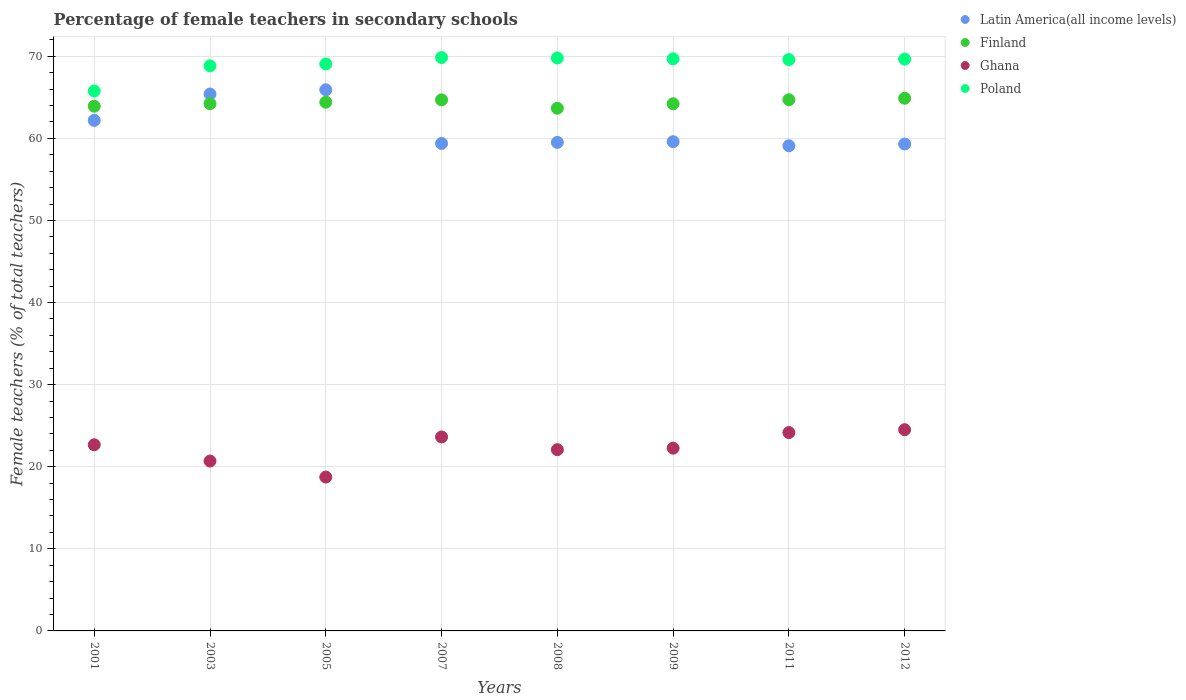What is the percentage of female teachers in Ghana in 2005?
Your response must be concise. 18.74. Across all years, what is the maximum percentage of female teachers in Finland?
Provide a short and direct response. 64.88. Across all years, what is the minimum percentage of female teachers in Finland?
Provide a succinct answer. 63.67. In which year was the percentage of female teachers in Finland maximum?
Your answer should be compact. 2012. In which year was the percentage of female teachers in Poland minimum?
Offer a terse response. 2001. What is the total percentage of female teachers in Poland in the graph?
Your answer should be very brief. 552.22. What is the difference between the percentage of female teachers in Ghana in 2009 and that in 2011?
Offer a terse response. -1.9. What is the difference between the percentage of female teachers in Finland in 2003 and the percentage of female teachers in Poland in 2005?
Give a very brief answer. -4.83. What is the average percentage of female teachers in Latin America(all income levels) per year?
Make the answer very short. 61.3. In the year 2012, what is the difference between the percentage of female teachers in Poland and percentage of female teachers in Finland?
Keep it short and to the point. 4.77. In how many years, is the percentage of female teachers in Poland greater than 24 %?
Ensure brevity in your answer.  8. What is the ratio of the percentage of female teachers in Latin America(all income levels) in 2001 to that in 2007?
Offer a terse response. 1.05. Is the difference between the percentage of female teachers in Poland in 2007 and 2011 greater than the difference between the percentage of female teachers in Finland in 2007 and 2011?
Provide a short and direct response. Yes. What is the difference between the highest and the second highest percentage of female teachers in Finland?
Make the answer very short. 0.18. What is the difference between the highest and the lowest percentage of female teachers in Ghana?
Ensure brevity in your answer.  5.77. In how many years, is the percentage of female teachers in Latin America(all income levels) greater than the average percentage of female teachers in Latin America(all income levels) taken over all years?
Your answer should be very brief. 3. Is the sum of the percentage of female teachers in Poland in 2007 and 2008 greater than the maximum percentage of female teachers in Latin America(all income levels) across all years?
Your answer should be very brief. Yes. Is it the case that in every year, the sum of the percentage of female teachers in Finland and percentage of female teachers in Latin America(all income levels)  is greater than the sum of percentage of female teachers in Poland and percentage of female teachers in Ghana?
Provide a succinct answer. No. Is the percentage of female teachers in Finland strictly greater than the percentage of female teachers in Ghana over the years?
Offer a terse response. Yes. How many years are there in the graph?
Offer a terse response. 8. Does the graph contain any zero values?
Make the answer very short. No. Does the graph contain grids?
Ensure brevity in your answer.  Yes. How many legend labels are there?
Your response must be concise. 4. What is the title of the graph?
Your answer should be compact. Percentage of female teachers in secondary schools. Does "Russian Federation" appear as one of the legend labels in the graph?
Make the answer very short. No. What is the label or title of the Y-axis?
Provide a succinct answer. Female teachers (% of total teachers). What is the Female teachers (% of total teachers) in Latin America(all income levels) in 2001?
Your response must be concise. 62.19. What is the Female teachers (% of total teachers) of Finland in 2001?
Make the answer very short. 63.92. What is the Female teachers (% of total teachers) in Ghana in 2001?
Your response must be concise. 22.67. What is the Female teachers (% of total teachers) of Poland in 2001?
Offer a very short reply. 65.77. What is the Female teachers (% of total teachers) in Latin America(all income levels) in 2003?
Offer a terse response. 65.4. What is the Female teachers (% of total teachers) of Finland in 2003?
Offer a terse response. 64.23. What is the Female teachers (% of total teachers) in Ghana in 2003?
Your answer should be compact. 20.69. What is the Female teachers (% of total teachers) of Poland in 2003?
Your answer should be very brief. 68.83. What is the Female teachers (% of total teachers) of Latin America(all income levels) in 2005?
Your answer should be compact. 65.92. What is the Female teachers (% of total teachers) of Finland in 2005?
Provide a short and direct response. 64.4. What is the Female teachers (% of total teachers) in Ghana in 2005?
Give a very brief answer. 18.74. What is the Female teachers (% of total teachers) of Poland in 2005?
Your answer should be compact. 69.06. What is the Female teachers (% of total teachers) of Latin America(all income levels) in 2007?
Keep it short and to the point. 59.38. What is the Female teachers (% of total teachers) of Finland in 2007?
Make the answer very short. 64.69. What is the Female teachers (% of total teachers) in Ghana in 2007?
Provide a succinct answer. 23.63. What is the Female teachers (% of total teachers) of Poland in 2007?
Your response must be concise. 69.84. What is the Female teachers (% of total teachers) of Latin America(all income levels) in 2008?
Your answer should be very brief. 59.51. What is the Female teachers (% of total teachers) of Finland in 2008?
Provide a succinct answer. 63.67. What is the Female teachers (% of total teachers) in Ghana in 2008?
Keep it short and to the point. 22.08. What is the Female teachers (% of total teachers) in Poland in 2008?
Offer a terse response. 69.79. What is the Female teachers (% of total teachers) of Latin America(all income levels) in 2009?
Offer a very short reply. 59.59. What is the Female teachers (% of total teachers) of Finland in 2009?
Your answer should be very brief. 64.21. What is the Female teachers (% of total teachers) of Ghana in 2009?
Ensure brevity in your answer.  22.26. What is the Female teachers (% of total teachers) of Poland in 2009?
Make the answer very short. 69.69. What is the Female teachers (% of total teachers) in Latin America(all income levels) in 2011?
Provide a succinct answer. 59.1. What is the Female teachers (% of total teachers) of Finland in 2011?
Offer a very short reply. 64.7. What is the Female teachers (% of total teachers) in Ghana in 2011?
Provide a succinct answer. 24.16. What is the Female teachers (% of total teachers) of Poland in 2011?
Your answer should be very brief. 69.6. What is the Female teachers (% of total teachers) of Latin America(all income levels) in 2012?
Make the answer very short. 59.31. What is the Female teachers (% of total teachers) of Finland in 2012?
Ensure brevity in your answer.  64.88. What is the Female teachers (% of total teachers) in Ghana in 2012?
Ensure brevity in your answer.  24.51. What is the Female teachers (% of total teachers) of Poland in 2012?
Offer a very short reply. 69.65. Across all years, what is the maximum Female teachers (% of total teachers) in Latin America(all income levels)?
Your answer should be compact. 65.92. Across all years, what is the maximum Female teachers (% of total teachers) in Finland?
Your answer should be very brief. 64.88. Across all years, what is the maximum Female teachers (% of total teachers) of Ghana?
Your response must be concise. 24.51. Across all years, what is the maximum Female teachers (% of total teachers) in Poland?
Offer a very short reply. 69.84. Across all years, what is the minimum Female teachers (% of total teachers) of Latin America(all income levels)?
Your answer should be very brief. 59.1. Across all years, what is the minimum Female teachers (% of total teachers) in Finland?
Make the answer very short. 63.67. Across all years, what is the minimum Female teachers (% of total teachers) of Ghana?
Ensure brevity in your answer.  18.74. Across all years, what is the minimum Female teachers (% of total teachers) of Poland?
Offer a terse response. 65.77. What is the total Female teachers (% of total teachers) of Latin America(all income levels) in the graph?
Your answer should be compact. 490.39. What is the total Female teachers (% of total teachers) of Finland in the graph?
Your response must be concise. 514.7. What is the total Female teachers (% of total teachers) of Ghana in the graph?
Make the answer very short. 178.75. What is the total Female teachers (% of total teachers) of Poland in the graph?
Provide a succinct answer. 552.22. What is the difference between the Female teachers (% of total teachers) of Latin America(all income levels) in 2001 and that in 2003?
Provide a succinct answer. -3.21. What is the difference between the Female teachers (% of total teachers) of Finland in 2001 and that in 2003?
Provide a succinct answer. -0.31. What is the difference between the Female teachers (% of total teachers) in Ghana in 2001 and that in 2003?
Your response must be concise. 1.98. What is the difference between the Female teachers (% of total teachers) in Poland in 2001 and that in 2003?
Keep it short and to the point. -3.07. What is the difference between the Female teachers (% of total teachers) in Latin America(all income levels) in 2001 and that in 2005?
Your answer should be compact. -3.73. What is the difference between the Female teachers (% of total teachers) in Finland in 2001 and that in 2005?
Give a very brief answer. -0.49. What is the difference between the Female teachers (% of total teachers) in Ghana in 2001 and that in 2005?
Provide a short and direct response. 3.93. What is the difference between the Female teachers (% of total teachers) in Poland in 2001 and that in 2005?
Make the answer very short. -3.3. What is the difference between the Female teachers (% of total teachers) of Latin America(all income levels) in 2001 and that in 2007?
Your response must be concise. 2.81. What is the difference between the Female teachers (% of total teachers) of Finland in 2001 and that in 2007?
Give a very brief answer. -0.77. What is the difference between the Female teachers (% of total teachers) in Ghana in 2001 and that in 2007?
Provide a succinct answer. -0.95. What is the difference between the Female teachers (% of total teachers) in Poland in 2001 and that in 2007?
Provide a succinct answer. -4.08. What is the difference between the Female teachers (% of total teachers) of Latin America(all income levels) in 2001 and that in 2008?
Make the answer very short. 2.68. What is the difference between the Female teachers (% of total teachers) of Finland in 2001 and that in 2008?
Your response must be concise. 0.25. What is the difference between the Female teachers (% of total teachers) of Ghana in 2001 and that in 2008?
Make the answer very short. 0.59. What is the difference between the Female teachers (% of total teachers) of Poland in 2001 and that in 2008?
Provide a succinct answer. -4.02. What is the difference between the Female teachers (% of total teachers) in Latin America(all income levels) in 2001 and that in 2009?
Make the answer very short. 2.59. What is the difference between the Female teachers (% of total teachers) in Finland in 2001 and that in 2009?
Your answer should be compact. -0.3. What is the difference between the Female teachers (% of total teachers) in Ghana in 2001 and that in 2009?
Provide a succinct answer. 0.41. What is the difference between the Female teachers (% of total teachers) of Poland in 2001 and that in 2009?
Your response must be concise. -3.92. What is the difference between the Female teachers (% of total teachers) of Latin America(all income levels) in 2001 and that in 2011?
Ensure brevity in your answer.  3.09. What is the difference between the Female teachers (% of total teachers) of Finland in 2001 and that in 2011?
Give a very brief answer. -0.79. What is the difference between the Female teachers (% of total teachers) in Ghana in 2001 and that in 2011?
Your answer should be compact. -1.49. What is the difference between the Female teachers (% of total teachers) of Poland in 2001 and that in 2011?
Provide a succinct answer. -3.83. What is the difference between the Female teachers (% of total teachers) in Latin America(all income levels) in 2001 and that in 2012?
Provide a short and direct response. 2.88. What is the difference between the Female teachers (% of total teachers) of Finland in 2001 and that in 2012?
Provide a succinct answer. -0.97. What is the difference between the Female teachers (% of total teachers) in Ghana in 2001 and that in 2012?
Provide a succinct answer. -1.84. What is the difference between the Female teachers (% of total teachers) in Poland in 2001 and that in 2012?
Offer a terse response. -3.88. What is the difference between the Female teachers (% of total teachers) of Latin America(all income levels) in 2003 and that in 2005?
Your response must be concise. -0.51. What is the difference between the Female teachers (% of total teachers) of Finland in 2003 and that in 2005?
Give a very brief answer. -0.17. What is the difference between the Female teachers (% of total teachers) of Ghana in 2003 and that in 2005?
Ensure brevity in your answer.  1.95. What is the difference between the Female teachers (% of total teachers) of Poland in 2003 and that in 2005?
Your response must be concise. -0.23. What is the difference between the Female teachers (% of total teachers) in Latin America(all income levels) in 2003 and that in 2007?
Your response must be concise. 6.02. What is the difference between the Female teachers (% of total teachers) of Finland in 2003 and that in 2007?
Your answer should be very brief. -0.46. What is the difference between the Female teachers (% of total teachers) in Ghana in 2003 and that in 2007?
Ensure brevity in your answer.  -2.93. What is the difference between the Female teachers (% of total teachers) of Poland in 2003 and that in 2007?
Ensure brevity in your answer.  -1.01. What is the difference between the Female teachers (% of total teachers) in Latin America(all income levels) in 2003 and that in 2008?
Make the answer very short. 5.89. What is the difference between the Female teachers (% of total teachers) in Finland in 2003 and that in 2008?
Your response must be concise. 0.56. What is the difference between the Female teachers (% of total teachers) in Ghana in 2003 and that in 2008?
Your answer should be very brief. -1.39. What is the difference between the Female teachers (% of total teachers) of Poland in 2003 and that in 2008?
Offer a very short reply. -0.95. What is the difference between the Female teachers (% of total teachers) of Latin America(all income levels) in 2003 and that in 2009?
Offer a terse response. 5.81. What is the difference between the Female teachers (% of total teachers) in Finland in 2003 and that in 2009?
Give a very brief answer. 0.02. What is the difference between the Female teachers (% of total teachers) in Ghana in 2003 and that in 2009?
Your answer should be compact. -1.57. What is the difference between the Female teachers (% of total teachers) in Poland in 2003 and that in 2009?
Your response must be concise. -0.85. What is the difference between the Female teachers (% of total teachers) of Latin America(all income levels) in 2003 and that in 2011?
Ensure brevity in your answer.  6.3. What is the difference between the Female teachers (% of total teachers) of Finland in 2003 and that in 2011?
Offer a terse response. -0.47. What is the difference between the Female teachers (% of total teachers) in Ghana in 2003 and that in 2011?
Offer a terse response. -3.47. What is the difference between the Female teachers (% of total teachers) of Poland in 2003 and that in 2011?
Make the answer very short. -0.76. What is the difference between the Female teachers (% of total teachers) of Latin America(all income levels) in 2003 and that in 2012?
Ensure brevity in your answer.  6.09. What is the difference between the Female teachers (% of total teachers) of Finland in 2003 and that in 2012?
Provide a succinct answer. -0.65. What is the difference between the Female teachers (% of total teachers) in Ghana in 2003 and that in 2012?
Make the answer very short. -3.82. What is the difference between the Female teachers (% of total teachers) of Poland in 2003 and that in 2012?
Your response must be concise. -0.82. What is the difference between the Female teachers (% of total teachers) in Latin America(all income levels) in 2005 and that in 2007?
Offer a terse response. 6.54. What is the difference between the Female teachers (% of total teachers) of Finland in 2005 and that in 2007?
Make the answer very short. -0.28. What is the difference between the Female teachers (% of total teachers) of Ghana in 2005 and that in 2007?
Ensure brevity in your answer.  -4.88. What is the difference between the Female teachers (% of total teachers) of Poland in 2005 and that in 2007?
Keep it short and to the point. -0.78. What is the difference between the Female teachers (% of total teachers) of Latin America(all income levels) in 2005 and that in 2008?
Make the answer very short. 6.41. What is the difference between the Female teachers (% of total teachers) of Finland in 2005 and that in 2008?
Make the answer very short. 0.73. What is the difference between the Female teachers (% of total teachers) in Ghana in 2005 and that in 2008?
Provide a succinct answer. -3.34. What is the difference between the Female teachers (% of total teachers) of Poland in 2005 and that in 2008?
Keep it short and to the point. -0.73. What is the difference between the Female teachers (% of total teachers) in Latin America(all income levels) in 2005 and that in 2009?
Your answer should be compact. 6.32. What is the difference between the Female teachers (% of total teachers) of Finland in 2005 and that in 2009?
Provide a short and direct response. 0.19. What is the difference between the Female teachers (% of total teachers) in Ghana in 2005 and that in 2009?
Offer a terse response. -3.52. What is the difference between the Female teachers (% of total teachers) of Poland in 2005 and that in 2009?
Your answer should be very brief. -0.63. What is the difference between the Female teachers (% of total teachers) in Latin America(all income levels) in 2005 and that in 2011?
Give a very brief answer. 6.82. What is the difference between the Female teachers (% of total teachers) in Finland in 2005 and that in 2011?
Provide a succinct answer. -0.3. What is the difference between the Female teachers (% of total teachers) of Ghana in 2005 and that in 2011?
Keep it short and to the point. -5.42. What is the difference between the Female teachers (% of total teachers) in Poland in 2005 and that in 2011?
Provide a succinct answer. -0.53. What is the difference between the Female teachers (% of total teachers) in Latin America(all income levels) in 2005 and that in 2012?
Make the answer very short. 6.61. What is the difference between the Female teachers (% of total teachers) in Finland in 2005 and that in 2012?
Your response must be concise. -0.48. What is the difference between the Female teachers (% of total teachers) of Ghana in 2005 and that in 2012?
Your answer should be very brief. -5.77. What is the difference between the Female teachers (% of total teachers) of Poland in 2005 and that in 2012?
Your answer should be very brief. -0.59. What is the difference between the Female teachers (% of total teachers) in Latin America(all income levels) in 2007 and that in 2008?
Ensure brevity in your answer.  -0.13. What is the difference between the Female teachers (% of total teachers) of Finland in 2007 and that in 2008?
Offer a very short reply. 1.02. What is the difference between the Female teachers (% of total teachers) of Ghana in 2007 and that in 2008?
Provide a short and direct response. 1.55. What is the difference between the Female teachers (% of total teachers) in Poland in 2007 and that in 2008?
Provide a succinct answer. 0.05. What is the difference between the Female teachers (% of total teachers) in Latin America(all income levels) in 2007 and that in 2009?
Offer a very short reply. -0.22. What is the difference between the Female teachers (% of total teachers) of Finland in 2007 and that in 2009?
Your response must be concise. 0.47. What is the difference between the Female teachers (% of total teachers) of Ghana in 2007 and that in 2009?
Make the answer very short. 1.36. What is the difference between the Female teachers (% of total teachers) in Poland in 2007 and that in 2009?
Your answer should be compact. 0.15. What is the difference between the Female teachers (% of total teachers) of Latin America(all income levels) in 2007 and that in 2011?
Your answer should be very brief. 0.28. What is the difference between the Female teachers (% of total teachers) in Finland in 2007 and that in 2011?
Keep it short and to the point. -0.02. What is the difference between the Female teachers (% of total teachers) in Ghana in 2007 and that in 2011?
Ensure brevity in your answer.  -0.54. What is the difference between the Female teachers (% of total teachers) of Poland in 2007 and that in 2011?
Keep it short and to the point. 0.25. What is the difference between the Female teachers (% of total teachers) in Latin America(all income levels) in 2007 and that in 2012?
Make the answer very short. 0.07. What is the difference between the Female teachers (% of total teachers) of Finland in 2007 and that in 2012?
Keep it short and to the point. -0.2. What is the difference between the Female teachers (% of total teachers) of Ghana in 2007 and that in 2012?
Give a very brief answer. -0.89. What is the difference between the Female teachers (% of total teachers) of Poland in 2007 and that in 2012?
Give a very brief answer. 0.19. What is the difference between the Female teachers (% of total teachers) of Latin America(all income levels) in 2008 and that in 2009?
Your response must be concise. -0.09. What is the difference between the Female teachers (% of total teachers) of Finland in 2008 and that in 2009?
Make the answer very short. -0.55. What is the difference between the Female teachers (% of total teachers) of Ghana in 2008 and that in 2009?
Ensure brevity in your answer.  -0.18. What is the difference between the Female teachers (% of total teachers) in Poland in 2008 and that in 2009?
Offer a very short reply. 0.1. What is the difference between the Female teachers (% of total teachers) in Latin America(all income levels) in 2008 and that in 2011?
Offer a very short reply. 0.41. What is the difference between the Female teachers (% of total teachers) of Finland in 2008 and that in 2011?
Offer a terse response. -1.04. What is the difference between the Female teachers (% of total teachers) of Ghana in 2008 and that in 2011?
Keep it short and to the point. -2.08. What is the difference between the Female teachers (% of total teachers) in Poland in 2008 and that in 2011?
Give a very brief answer. 0.19. What is the difference between the Female teachers (% of total teachers) of Latin America(all income levels) in 2008 and that in 2012?
Ensure brevity in your answer.  0.2. What is the difference between the Female teachers (% of total teachers) of Finland in 2008 and that in 2012?
Your answer should be compact. -1.22. What is the difference between the Female teachers (% of total teachers) of Ghana in 2008 and that in 2012?
Your response must be concise. -2.43. What is the difference between the Female teachers (% of total teachers) of Poland in 2008 and that in 2012?
Your answer should be very brief. 0.14. What is the difference between the Female teachers (% of total teachers) of Latin America(all income levels) in 2009 and that in 2011?
Make the answer very short. 0.5. What is the difference between the Female teachers (% of total teachers) in Finland in 2009 and that in 2011?
Your answer should be compact. -0.49. What is the difference between the Female teachers (% of total teachers) of Ghana in 2009 and that in 2011?
Provide a short and direct response. -1.9. What is the difference between the Female teachers (% of total teachers) in Poland in 2009 and that in 2011?
Your response must be concise. 0.09. What is the difference between the Female teachers (% of total teachers) in Latin America(all income levels) in 2009 and that in 2012?
Give a very brief answer. 0.28. What is the difference between the Female teachers (% of total teachers) of Finland in 2009 and that in 2012?
Keep it short and to the point. -0.67. What is the difference between the Female teachers (% of total teachers) of Ghana in 2009 and that in 2012?
Provide a short and direct response. -2.25. What is the difference between the Female teachers (% of total teachers) in Poland in 2009 and that in 2012?
Provide a succinct answer. 0.04. What is the difference between the Female teachers (% of total teachers) of Latin America(all income levels) in 2011 and that in 2012?
Provide a short and direct response. -0.21. What is the difference between the Female teachers (% of total teachers) in Finland in 2011 and that in 2012?
Your answer should be compact. -0.18. What is the difference between the Female teachers (% of total teachers) of Ghana in 2011 and that in 2012?
Your response must be concise. -0.35. What is the difference between the Female teachers (% of total teachers) in Poland in 2011 and that in 2012?
Give a very brief answer. -0.05. What is the difference between the Female teachers (% of total teachers) in Latin America(all income levels) in 2001 and the Female teachers (% of total teachers) in Finland in 2003?
Offer a terse response. -2.04. What is the difference between the Female teachers (% of total teachers) of Latin America(all income levels) in 2001 and the Female teachers (% of total teachers) of Ghana in 2003?
Offer a very short reply. 41.49. What is the difference between the Female teachers (% of total teachers) of Latin America(all income levels) in 2001 and the Female teachers (% of total teachers) of Poland in 2003?
Your answer should be very brief. -6.65. What is the difference between the Female teachers (% of total teachers) of Finland in 2001 and the Female teachers (% of total teachers) of Ghana in 2003?
Give a very brief answer. 43.22. What is the difference between the Female teachers (% of total teachers) in Finland in 2001 and the Female teachers (% of total teachers) in Poland in 2003?
Give a very brief answer. -4.92. What is the difference between the Female teachers (% of total teachers) of Ghana in 2001 and the Female teachers (% of total teachers) of Poland in 2003?
Keep it short and to the point. -46.16. What is the difference between the Female teachers (% of total teachers) in Latin America(all income levels) in 2001 and the Female teachers (% of total teachers) in Finland in 2005?
Your answer should be very brief. -2.21. What is the difference between the Female teachers (% of total teachers) of Latin America(all income levels) in 2001 and the Female teachers (% of total teachers) of Ghana in 2005?
Ensure brevity in your answer.  43.45. What is the difference between the Female teachers (% of total teachers) in Latin America(all income levels) in 2001 and the Female teachers (% of total teachers) in Poland in 2005?
Ensure brevity in your answer.  -6.87. What is the difference between the Female teachers (% of total teachers) in Finland in 2001 and the Female teachers (% of total teachers) in Ghana in 2005?
Your answer should be compact. 45.17. What is the difference between the Female teachers (% of total teachers) in Finland in 2001 and the Female teachers (% of total teachers) in Poland in 2005?
Make the answer very short. -5.15. What is the difference between the Female teachers (% of total teachers) in Ghana in 2001 and the Female teachers (% of total teachers) in Poland in 2005?
Ensure brevity in your answer.  -46.39. What is the difference between the Female teachers (% of total teachers) in Latin America(all income levels) in 2001 and the Female teachers (% of total teachers) in Finland in 2007?
Give a very brief answer. -2.5. What is the difference between the Female teachers (% of total teachers) in Latin America(all income levels) in 2001 and the Female teachers (% of total teachers) in Ghana in 2007?
Make the answer very short. 38.56. What is the difference between the Female teachers (% of total teachers) in Latin America(all income levels) in 2001 and the Female teachers (% of total teachers) in Poland in 2007?
Ensure brevity in your answer.  -7.65. What is the difference between the Female teachers (% of total teachers) of Finland in 2001 and the Female teachers (% of total teachers) of Ghana in 2007?
Your answer should be very brief. 40.29. What is the difference between the Female teachers (% of total teachers) of Finland in 2001 and the Female teachers (% of total teachers) of Poland in 2007?
Provide a succinct answer. -5.93. What is the difference between the Female teachers (% of total teachers) of Ghana in 2001 and the Female teachers (% of total teachers) of Poland in 2007?
Make the answer very short. -47.17. What is the difference between the Female teachers (% of total teachers) of Latin America(all income levels) in 2001 and the Female teachers (% of total teachers) of Finland in 2008?
Keep it short and to the point. -1.48. What is the difference between the Female teachers (% of total teachers) in Latin America(all income levels) in 2001 and the Female teachers (% of total teachers) in Ghana in 2008?
Your answer should be very brief. 40.11. What is the difference between the Female teachers (% of total teachers) of Latin America(all income levels) in 2001 and the Female teachers (% of total teachers) of Poland in 2008?
Offer a terse response. -7.6. What is the difference between the Female teachers (% of total teachers) in Finland in 2001 and the Female teachers (% of total teachers) in Ghana in 2008?
Offer a terse response. 41.84. What is the difference between the Female teachers (% of total teachers) in Finland in 2001 and the Female teachers (% of total teachers) in Poland in 2008?
Give a very brief answer. -5.87. What is the difference between the Female teachers (% of total teachers) of Ghana in 2001 and the Female teachers (% of total teachers) of Poland in 2008?
Offer a terse response. -47.11. What is the difference between the Female teachers (% of total teachers) of Latin America(all income levels) in 2001 and the Female teachers (% of total teachers) of Finland in 2009?
Make the answer very short. -2.03. What is the difference between the Female teachers (% of total teachers) of Latin America(all income levels) in 2001 and the Female teachers (% of total teachers) of Ghana in 2009?
Your answer should be very brief. 39.92. What is the difference between the Female teachers (% of total teachers) in Latin America(all income levels) in 2001 and the Female teachers (% of total teachers) in Poland in 2009?
Offer a terse response. -7.5. What is the difference between the Female teachers (% of total teachers) of Finland in 2001 and the Female teachers (% of total teachers) of Ghana in 2009?
Ensure brevity in your answer.  41.65. What is the difference between the Female teachers (% of total teachers) of Finland in 2001 and the Female teachers (% of total teachers) of Poland in 2009?
Give a very brief answer. -5.77. What is the difference between the Female teachers (% of total teachers) in Ghana in 2001 and the Female teachers (% of total teachers) in Poland in 2009?
Offer a terse response. -47.01. What is the difference between the Female teachers (% of total teachers) of Latin America(all income levels) in 2001 and the Female teachers (% of total teachers) of Finland in 2011?
Offer a very short reply. -2.52. What is the difference between the Female teachers (% of total teachers) in Latin America(all income levels) in 2001 and the Female teachers (% of total teachers) in Ghana in 2011?
Provide a succinct answer. 38.03. What is the difference between the Female teachers (% of total teachers) in Latin America(all income levels) in 2001 and the Female teachers (% of total teachers) in Poland in 2011?
Your response must be concise. -7.41. What is the difference between the Female teachers (% of total teachers) of Finland in 2001 and the Female teachers (% of total teachers) of Ghana in 2011?
Offer a very short reply. 39.75. What is the difference between the Female teachers (% of total teachers) of Finland in 2001 and the Female teachers (% of total teachers) of Poland in 2011?
Provide a short and direct response. -5.68. What is the difference between the Female teachers (% of total teachers) of Ghana in 2001 and the Female teachers (% of total teachers) of Poland in 2011?
Offer a very short reply. -46.92. What is the difference between the Female teachers (% of total teachers) in Latin America(all income levels) in 2001 and the Female teachers (% of total teachers) in Finland in 2012?
Give a very brief answer. -2.7. What is the difference between the Female teachers (% of total teachers) of Latin America(all income levels) in 2001 and the Female teachers (% of total teachers) of Ghana in 2012?
Offer a terse response. 37.68. What is the difference between the Female teachers (% of total teachers) of Latin America(all income levels) in 2001 and the Female teachers (% of total teachers) of Poland in 2012?
Ensure brevity in your answer.  -7.46. What is the difference between the Female teachers (% of total teachers) in Finland in 2001 and the Female teachers (% of total teachers) in Ghana in 2012?
Your answer should be very brief. 39.4. What is the difference between the Female teachers (% of total teachers) of Finland in 2001 and the Female teachers (% of total teachers) of Poland in 2012?
Keep it short and to the point. -5.73. What is the difference between the Female teachers (% of total teachers) in Ghana in 2001 and the Female teachers (% of total teachers) in Poland in 2012?
Make the answer very short. -46.98. What is the difference between the Female teachers (% of total teachers) in Latin America(all income levels) in 2003 and the Female teachers (% of total teachers) in Finland in 2005?
Your answer should be compact. 1. What is the difference between the Female teachers (% of total teachers) in Latin America(all income levels) in 2003 and the Female teachers (% of total teachers) in Ghana in 2005?
Offer a very short reply. 46.66. What is the difference between the Female teachers (% of total teachers) of Latin America(all income levels) in 2003 and the Female teachers (% of total teachers) of Poland in 2005?
Keep it short and to the point. -3.66. What is the difference between the Female teachers (% of total teachers) in Finland in 2003 and the Female teachers (% of total teachers) in Ghana in 2005?
Provide a short and direct response. 45.49. What is the difference between the Female teachers (% of total teachers) in Finland in 2003 and the Female teachers (% of total teachers) in Poland in 2005?
Provide a short and direct response. -4.83. What is the difference between the Female teachers (% of total teachers) of Ghana in 2003 and the Female teachers (% of total teachers) of Poland in 2005?
Keep it short and to the point. -48.37. What is the difference between the Female teachers (% of total teachers) in Latin America(all income levels) in 2003 and the Female teachers (% of total teachers) in Finland in 2007?
Provide a succinct answer. 0.71. What is the difference between the Female teachers (% of total teachers) in Latin America(all income levels) in 2003 and the Female teachers (% of total teachers) in Ghana in 2007?
Your response must be concise. 41.78. What is the difference between the Female teachers (% of total teachers) of Latin America(all income levels) in 2003 and the Female teachers (% of total teachers) of Poland in 2007?
Offer a terse response. -4.44. What is the difference between the Female teachers (% of total teachers) in Finland in 2003 and the Female teachers (% of total teachers) in Ghana in 2007?
Provide a short and direct response. 40.61. What is the difference between the Female teachers (% of total teachers) in Finland in 2003 and the Female teachers (% of total teachers) in Poland in 2007?
Keep it short and to the point. -5.61. What is the difference between the Female teachers (% of total teachers) of Ghana in 2003 and the Female teachers (% of total teachers) of Poland in 2007?
Give a very brief answer. -49.15. What is the difference between the Female teachers (% of total teachers) of Latin America(all income levels) in 2003 and the Female teachers (% of total teachers) of Finland in 2008?
Provide a short and direct response. 1.73. What is the difference between the Female teachers (% of total teachers) in Latin America(all income levels) in 2003 and the Female teachers (% of total teachers) in Ghana in 2008?
Ensure brevity in your answer.  43.32. What is the difference between the Female teachers (% of total teachers) in Latin America(all income levels) in 2003 and the Female teachers (% of total teachers) in Poland in 2008?
Ensure brevity in your answer.  -4.39. What is the difference between the Female teachers (% of total teachers) in Finland in 2003 and the Female teachers (% of total teachers) in Ghana in 2008?
Provide a succinct answer. 42.15. What is the difference between the Female teachers (% of total teachers) of Finland in 2003 and the Female teachers (% of total teachers) of Poland in 2008?
Offer a very short reply. -5.56. What is the difference between the Female teachers (% of total teachers) in Ghana in 2003 and the Female teachers (% of total teachers) in Poland in 2008?
Make the answer very short. -49.09. What is the difference between the Female teachers (% of total teachers) in Latin America(all income levels) in 2003 and the Female teachers (% of total teachers) in Finland in 2009?
Give a very brief answer. 1.19. What is the difference between the Female teachers (% of total teachers) in Latin America(all income levels) in 2003 and the Female teachers (% of total teachers) in Ghana in 2009?
Make the answer very short. 43.14. What is the difference between the Female teachers (% of total teachers) in Latin America(all income levels) in 2003 and the Female teachers (% of total teachers) in Poland in 2009?
Provide a short and direct response. -4.29. What is the difference between the Female teachers (% of total teachers) in Finland in 2003 and the Female teachers (% of total teachers) in Ghana in 2009?
Provide a succinct answer. 41.97. What is the difference between the Female teachers (% of total teachers) of Finland in 2003 and the Female teachers (% of total teachers) of Poland in 2009?
Offer a terse response. -5.46. What is the difference between the Female teachers (% of total teachers) in Ghana in 2003 and the Female teachers (% of total teachers) in Poland in 2009?
Your response must be concise. -48.99. What is the difference between the Female teachers (% of total teachers) of Latin America(all income levels) in 2003 and the Female teachers (% of total teachers) of Finland in 2011?
Your answer should be compact. 0.7. What is the difference between the Female teachers (% of total teachers) of Latin America(all income levels) in 2003 and the Female teachers (% of total teachers) of Ghana in 2011?
Your response must be concise. 41.24. What is the difference between the Female teachers (% of total teachers) of Latin America(all income levels) in 2003 and the Female teachers (% of total teachers) of Poland in 2011?
Offer a terse response. -4.2. What is the difference between the Female teachers (% of total teachers) of Finland in 2003 and the Female teachers (% of total teachers) of Ghana in 2011?
Make the answer very short. 40.07. What is the difference between the Female teachers (% of total teachers) in Finland in 2003 and the Female teachers (% of total teachers) in Poland in 2011?
Your answer should be compact. -5.37. What is the difference between the Female teachers (% of total teachers) of Ghana in 2003 and the Female teachers (% of total teachers) of Poland in 2011?
Ensure brevity in your answer.  -48.9. What is the difference between the Female teachers (% of total teachers) of Latin America(all income levels) in 2003 and the Female teachers (% of total teachers) of Finland in 2012?
Your answer should be very brief. 0.52. What is the difference between the Female teachers (% of total teachers) of Latin America(all income levels) in 2003 and the Female teachers (% of total teachers) of Ghana in 2012?
Give a very brief answer. 40.89. What is the difference between the Female teachers (% of total teachers) in Latin America(all income levels) in 2003 and the Female teachers (% of total teachers) in Poland in 2012?
Offer a terse response. -4.25. What is the difference between the Female teachers (% of total teachers) of Finland in 2003 and the Female teachers (% of total teachers) of Ghana in 2012?
Offer a very short reply. 39.72. What is the difference between the Female teachers (% of total teachers) of Finland in 2003 and the Female teachers (% of total teachers) of Poland in 2012?
Ensure brevity in your answer.  -5.42. What is the difference between the Female teachers (% of total teachers) in Ghana in 2003 and the Female teachers (% of total teachers) in Poland in 2012?
Provide a short and direct response. -48.95. What is the difference between the Female teachers (% of total teachers) in Latin America(all income levels) in 2005 and the Female teachers (% of total teachers) in Finland in 2007?
Offer a terse response. 1.23. What is the difference between the Female teachers (% of total teachers) in Latin America(all income levels) in 2005 and the Female teachers (% of total teachers) in Ghana in 2007?
Offer a very short reply. 42.29. What is the difference between the Female teachers (% of total teachers) of Latin America(all income levels) in 2005 and the Female teachers (% of total teachers) of Poland in 2007?
Offer a terse response. -3.93. What is the difference between the Female teachers (% of total teachers) in Finland in 2005 and the Female teachers (% of total teachers) in Ghana in 2007?
Offer a very short reply. 40.78. What is the difference between the Female teachers (% of total teachers) of Finland in 2005 and the Female teachers (% of total teachers) of Poland in 2007?
Your answer should be very brief. -5.44. What is the difference between the Female teachers (% of total teachers) in Ghana in 2005 and the Female teachers (% of total teachers) in Poland in 2007?
Offer a terse response. -51.1. What is the difference between the Female teachers (% of total teachers) in Latin America(all income levels) in 2005 and the Female teachers (% of total teachers) in Finland in 2008?
Your answer should be compact. 2.25. What is the difference between the Female teachers (% of total teachers) of Latin America(all income levels) in 2005 and the Female teachers (% of total teachers) of Ghana in 2008?
Your answer should be compact. 43.84. What is the difference between the Female teachers (% of total teachers) of Latin America(all income levels) in 2005 and the Female teachers (% of total teachers) of Poland in 2008?
Keep it short and to the point. -3.87. What is the difference between the Female teachers (% of total teachers) in Finland in 2005 and the Female teachers (% of total teachers) in Ghana in 2008?
Your answer should be compact. 42.32. What is the difference between the Female teachers (% of total teachers) of Finland in 2005 and the Female teachers (% of total teachers) of Poland in 2008?
Your response must be concise. -5.39. What is the difference between the Female teachers (% of total teachers) of Ghana in 2005 and the Female teachers (% of total teachers) of Poland in 2008?
Provide a short and direct response. -51.04. What is the difference between the Female teachers (% of total teachers) of Latin America(all income levels) in 2005 and the Female teachers (% of total teachers) of Finland in 2009?
Your answer should be compact. 1.7. What is the difference between the Female teachers (% of total teachers) in Latin America(all income levels) in 2005 and the Female teachers (% of total teachers) in Ghana in 2009?
Keep it short and to the point. 43.65. What is the difference between the Female teachers (% of total teachers) of Latin America(all income levels) in 2005 and the Female teachers (% of total teachers) of Poland in 2009?
Keep it short and to the point. -3.77. What is the difference between the Female teachers (% of total teachers) of Finland in 2005 and the Female teachers (% of total teachers) of Ghana in 2009?
Your answer should be compact. 42.14. What is the difference between the Female teachers (% of total teachers) of Finland in 2005 and the Female teachers (% of total teachers) of Poland in 2009?
Keep it short and to the point. -5.29. What is the difference between the Female teachers (% of total teachers) in Ghana in 2005 and the Female teachers (% of total teachers) in Poland in 2009?
Offer a terse response. -50.95. What is the difference between the Female teachers (% of total teachers) of Latin America(all income levels) in 2005 and the Female teachers (% of total teachers) of Finland in 2011?
Offer a terse response. 1.21. What is the difference between the Female teachers (% of total teachers) of Latin America(all income levels) in 2005 and the Female teachers (% of total teachers) of Ghana in 2011?
Your answer should be compact. 41.75. What is the difference between the Female teachers (% of total teachers) in Latin America(all income levels) in 2005 and the Female teachers (% of total teachers) in Poland in 2011?
Your response must be concise. -3.68. What is the difference between the Female teachers (% of total teachers) of Finland in 2005 and the Female teachers (% of total teachers) of Ghana in 2011?
Make the answer very short. 40.24. What is the difference between the Female teachers (% of total teachers) of Finland in 2005 and the Female teachers (% of total teachers) of Poland in 2011?
Make the answer very short. -5.19. What is the difference between the Female teachers (% of total teachers) of Ghana in 2005 and the Female teachers (% of total teachers) of Poland in 2011?
Make the answer very short. -50.85. What is the difference between the Female teachers (% of total teachers) of Latin America(all income levels) in 2005 and the Female teachers (% of total teachers) of Finland in 2012?
Your answer should be very brief. 1.03. What is the difference between the Female teachers (% of total teachers) of Latin America(all income levels) in 2005 and the Female teachers (% of total teachers) of Ghana in 2012?
Keep it short and to the point. 41.4. What is the difference between the Female teachers (% of total teachers) in Latin America(all income levels) in 2005 and the Female teachers (% of total teachers) in Poland in 2012?
Your answer should be compact. -3.73. What is the difference between the Female teachers (% of total teachers) in Finland in 2005 and the Female teachers (% of total teachers) in Ghana in 2012?
Keep it short and to the point. 39.89. What is the difference between the Female teachers (% of total teachers) in Finland in 2005 and the Female teachers (% of total teachers) in Poland in 2012?
Offer a terse response. -5.25. What is the difference between the Female teachers (% of total teachers) of Ghana in 2005 and the Female teachers (% of total teachers) of Poland in 2012?
Offer a very short reply. -50.91. What is the difference between the Female teachers (% of total teachers) in Latin America(all income levels) in 2007 and the Female teachers (% of total teachers) in Finland in 2008?
Your answer should be very brief. -4.29. What is the difference between the Female teachers (% of total teachers) in Latin America(all income levels) in 2007 and the Female teachers (% of total teachers) in Ghana in 2008?
Offer a very short reply. 37.3. What is the difference between the Female teachers (% of total teachers) in Latin America(all income levels) in 2007 and the Female teachers (% of total teachers) in Poland in 2008?
Provide a succinct answer. -10.41. What is the difference between the Female teachers (% of total teachers) in Finland in 2007 and the Female teachers (% of total teachers) in Ghana in 2008?
Give a very brief answer. 42.61. What is the difference between the Female teachers (% of total teachers) of Finland in 2007 and the Female teachers (% of total teachers) of Poland in 2008?
Keep it short and to the point. -5.1. What is the difference between the Female teachers (% of total teachers) of Ghana in 2007 and the Female teachers (% of total teachers) of Poland in 2008?
Offer a very short reply. -46.16. What is the difference between the Female teachers (% of total teachers) in Latin America(all income levels) in 2007 and the Female teachers (% of total teachers) in Finland in 2009?
Ensure brevity in your answer.  -4.84. What is the difference between the Female teachers (% of total teachers) of Latin America(all income levels) in 2007 and the Female teachers (% of total teachers) of Ghana in 2009?
Your response must be concise. 37.11. What is the difference between the Female teachers (% of total teachers) in Latin America(all income levels) in 2007 and the Female teachers (% of total teachers) in Poland in 2009?
Provide a succinct answer. -10.31. What is the difference between the Female teachers (% of total teachers) of Finland in 2007 and the Female teachers (% of total teachers) of Ghana in 2009?
Your answer should be compact. 42.42. What is the difference between the Female teachers (% of total teachers) of Finland in 2007 and the Female teachers (% of total teachers) of Poland in 2009?
Offer a very short reply. -5. What is the difference between the Female teachers (% of total teachers) in Ghana in 2007 and the Female teachers (% of total teachers) in Poland in 2009?
Your response must be concise. -46.06. What is the difference between the Female teachers (% of total teachers) in Latin America(all income levels) in 2007 and the Female teachers (% of total teachers) in Finland in 2011?
Offer a terse response. -5.33. What is the difference between the Female teachers (% of total teachers) in Latin America(all income levels) in 2007 and the Female teachers (% of total teachers) in Ghana in 2011?
Your answer should be compact. 35.21. What is the difference between the Female teachers (% of total teachers) in Latin America(all income levels) in 2007 and the Female teachers (% of total teachers) in Poland in 2011?
Give a very brief answer. -10.22. What is the difference between the Female teachers (% of total teachers) in Finland in 2007 and the Female teachers (% of total teachers) in Ghana in 2011?
Ensure brevity in your answer.  40.52. What is the difference between the Female teachers (% of total teachers) in Finland in 2007 and the Female teachers (% of total teachers) in Poland in 2011?
Keep it short and to the point. -4.91. What is the difference between the Female teachers (% of total teachers) in Ghana in 2007 and the Female teachers (% of total teachers) in Poland in 2011?
Your answer should be very brief. -45.97. What is the difference between the Female teachers (% of total teachers) in Latin America(all income levels) in 2007 and the Female teachers (% of total teachers) in Finland in 2012?
Your response must be concise. -5.51. What is the difference between the Female teachers (% of total teachers) of Latin America(all income levels) in 2007 and the Female teachers (% of total teachers) of Ghana in 2012?
Offer a terse response. 34.87. What is the difference between the Female teachers (% of total teachers) in Latin America(all income levels) in 2007 and the Female teachers (% of total teachers) in Poland in 2012?
Give a very brief answer. -10.27. What is the difference between the Female teachers (% of total teachers) of Finland in 2007 and the Female teachers (% of total teachers) of Ghana in 2012?
Offer a terse response. 40.17. What is the difference between the Female teachers (% of total teachers) in Finland in 2007 and the Female teachers (% of total teachers) in Poland in 2012?
Make the answer very short. -4.96. What is the difference between the Female teachers (% of total teachers) in Ghana in 2007 and the Female teachers (% of total teachers) in Poland in 2012?
Offer a very short reply. -46.02. What is the difference between the Female teachers (% of total teachers) of Latin America(all income levels) in 2008 and the Female teachers (% of total teachers) of Finland in 2009?
Keep it short and to the point. -4.71. What is the difference between the Female teachers (% of total teachers) in Latin America(all income levels) in 2008 and the Female teachers (% of total teachers) in Ghana in 2009?
Give a very brief answer. 37.24. What is the difference between the Female teachers (% of total teachers) in Latin America(all income levels) in 2008 and the Female teachers (% of total teachers) in Poland in 2009?
Keep it short and to the point. -10.18. What is the difference between the Female teachers (% of total teachers) in Finland in 2008 and the Female teachers (% of total teachers) in Ghana in 2009?
Ensure brevity in your answer.  41.4. What is the difference between the Female teachers (% of total teachers) in Finland in 2008 and the Female teachers (% of total teachers) in Poland in 2009?
Offer a very short reply. -6.02. What is the difference between the Female teachers (% of total teachers) in Ghana in 2008 and the Female teachers (% of total teachers) in Poland in 2009?
Your response must be concise. -47.61. What is the difference between the Female teachers (% of total teachers) in Latin America(all income levels) in 2008 and the Female teachers (% of total teachers) in Finland in 2011?
Your answer should be compact. -5.2. What is the difference between the Female teachers (% of total teachers) of Latin America(all income levels) in 2008 and the Female teachers (% of total teachers) of Ghana in 2011?
Make the answer very short. 35.34. What is the difference between the Female teachers (% of total teachers) in Latin America(all income levels) in 2008 and the Female teachers (% of total teachers) in Poland in 2011?
Offer a terse response. -10.09. What is the difference between the Female teachers (% of total teachers) in Finland in 2008 and the Female teachers (% of total teachers) in Ghana in 2011?
Provide a succinct answer. 39.5. What is the difference between the Female teachers (% of total teachers) in Finland in 2008 and the Female teachers (% of total teachers) in Poland in 2011?
Your response must be concise. -5.93. What is the difference between the Female teachers (% of total teachers) in Ghana in 2008 and the Female teachers (% of total teachers) in Poland in 2011?
Your response must be concise. -47.52. What is the difference between the Female teachers (% of total teachers) of Latin America(all income levels) in 2008 and the Female teachers (% of total teachers) of Finland in 2012?
Offer a very short reply. -5.38. What is the difference between the Female teachers (% of total teachers) of Latin America(all income levels) in 2008 and the Female teachers (% of total teachers) of Ghana in 2012?
Ensure brevity in your answer.  34.99. What is the difference between the Female teachers (% of total teachers) of Latin America(all income levels) in 2008 and the Female teachers (% of total teachers) of Poland in 2012?
Give a very brief answer. -10.14. What is the difference between the Female teachers (% of total teachers) in Finland in 2008 and the Female teachers (% of total teachers) in Ghana in 2012?
Provide a short and direct response. 39.16. What is the difference between the Female teachers (% of total teachers) in Finland in 2008 and the Female teachers (% of total teachers) in Poland in 2012?
Make the answer very short. -5.98. What is the difference between the Female teachers (% of total teachers) in Ghana in 2008 and the Female teachers (% of total teachers) in Poland in 2012?
Provide a succinct answer. -47.57. What is the difference between the Female teachers (% of total teachers) of Latin America(all income levels) in 2009 and the Female teachers (% of total teachers) of Finland in 2011?
Ensure brevity in your answer.  -5.11. What is the difference between the Female teachers (% of total teachers) in Latin America(all income levels) in 2009 and the Female teachers (% of total teachers) in Ghana in 2011?
Keep it short and to the point. 35.43. What is the difference between the Female teachers (% of total teachers) of Latin America(all income levels) in 2009 and the Female teachers (% of total teachers) of Poland in 2011?
Ensure brevity in your answer.  -10. What is the difference between the Female teachers (% of total teachers) of Finland in 2009 and the Female teachers (% of total teachers) of Ghana in 2011?
Ensure brevity in your answer.  40.05. What is the difference between the Female teachers (% of total teachers) in Finland in 2009 and the Female teachers (% of total teachers) in Poland in 2011?
Keep it short and to the point. -5.38. What is the difference between the Female teachers (% of total teachers) of Ghana in 2009 and the Female teachers (% of total teachers) of Poland in 2011?
Keep it short and to the point. -47.33. What is the difference between the Female teachers (% of total teachers) of Latin America(all income levels) in 2009 and the Female teachers (% of total teachers) of Finland in 2012?
Provide a short and direct response. -5.29. What is the difference between the Female teachers (% of total teachers) of Latin America(all income levels) in 2009 and the Female teachers (% of total teachers) of Ghana in 2012?
Your answer should be compact. 35.08. What is the difference between the Female teachers (% of total teachers) in Latin America(all income levels) in 2009 and the Female teachers (% of total teachers) in Poland in 2012?
Your answer should be very brief. -10.06. What is the difference between the Female teachers (% of total teachers) in Finland in 2009 and the Female teachers (% of total teachers) in Ghana in 2012?
Your answer should be very brief. 39.7. What is the difference between the Female teachers (% of total teachers) in Finland in 2009 and the Female teachers (% of total teachers) in Poland in 2012?
Offer a very short reply. -5.43. What is the difference between the Female teachers (% of total teachers) of Ghana in 2009 and the Female teachers (% of total teachers) of Poland in 2012?
Your response must be concise. -47.39. What is the difference between the Female teachers (% of total teachers) in Latin America(all income levels) in 2011 and the Female teachers (% of total teachers) in Finland in 2012?
Make the answer very short. -5.79. What is the difference between the Female teachers (% of total teachers) of Latin America(all income levels) in 2011 and the Female teachers (% of total teachers) of Ghana in 2012?
Your answer should be compact. 34.59. What is the difference between the Female teachers (% of total teachers) of Latin America(all income levels) in 2011 and the Female teachers (% of total teachers) of Poland in 2012?
Keep it short and to the point. -10.55. What is the difference between the Female teachers (% of total teachers) of Finland in 2011 and the Female teachers (% of total teachers) of Ghana in 2012?
Your answer should be very brief. 40.19. What is the difference between the Female teachers (% of total teachers) of Finland in 2011 and the Female teachers (% of total teachers) of Poland in 2012?
Give a very brief answer. -4.94. What is the difference between the Female teachers (% of total teachers) of Ghana in 2011 and the Female teachers (% of total teachers) of Poland in 2012?
Keep it short and to the point. -45.49. What is the average Female teachers (% of total teachers) in Latin America(all income levels) per year?
Ensure brevity in your answer.  61.3. What is the average Female teachers (% of total teachers) in Finland per year?
Keep it short and to the point. 64.34. What is the average Female teachers (% of total teachers) in Ghana per year?
Offer a very short reply. 22.34. What is the average Female teachers (% of total teachers) of Poland per year?
Your response must be concise. 69.03. In the year 2001, what is the difference between the Female teachers (% of total teachers) of Latin America(all income levels) and Female teachers (% of total teachers) of Finland?
Keep it short and to the point. -1.73. In the year 2001, what is the difference between the Female teachers (% of total teachers) in Latin America(all income levels) and Female teachers (% of total teachers) in Ghana?
Provide a succinct answer. 39.51. In the year 2001, what is the difference between the Female teachers (% of total teachers) in Latin America(all income levels) and Female teachers (% of total teachers) in Poland?
Your answer should be compact. -3.58. In the year 2001, what is the difference between the Female teachers (% of total teachers) in Finland and Female teachers (% of total teachers) in Ghana?
Keep it short and to the point. 41.24. In the year 2001, what is the difference between the Female teachers (% of total teachers) in Finland and Female teachers (% of total teachers) in Poland?
Your answer should be very brief. -1.85. In the year 2001, what is the difference between the Female teachers (% of total teachers) in Ghana and Female teachers (% of total teachers) in Poland?
Give a very brief answer. -43.09. In the year 2003, what is the difference between the Female teachers (% of total teachers) in Latin America(all income levels) and Female teachers (% of total teachers) in Finland?
Provide a short and direct response. 1.17. In the year 2003, what is the difference between the Female teachers (% of total teachers) of Latin America(all income levels) and Female teachers (% of total teachers) of Ghana?
Keep it short and to the point. 44.71. In the year 2003, what is the difference between the Female teachers (% of total teachers) in Latin America(all income levels) and Female teachers (% of total teachers) in Poland?
Keep it short and to the point. -3.43. In the year 2003, what is the difference between the Female teachers (% of total teachers) in Finland and Female teachers (% of total teachers) in Ghana?
Make the answer very short. 43.54. In the year 2003, what is the difference between the Female teachers (% of total teachers) in Finland and Female teachers (% of total teachers) in Poland?
Provide a short and direct response. -4.6. In the year 2003, what is the difference between the Female teachers (% of total teachers) of Ghana and Female teachers (% of total teachers) of Poland?
Provide a succinct answer. -48.14. In the year 2005, what is the difference between the Female teachers (% of total teachers) of Latin America(all income levels) and Female teachers (% of total teachers) of Finland?
Ensure brevity in your answer.  1.51. In the year 2005, what is the difference between the Female teachers (% of total teachers) in Latin America(all income levels) and Female teachers (% of total teachers) in Ghana?
Keep it short and to the point. 47.17. In the year 2005, what is the difference between the Female teachers (% of total teachers) of Latin America(all income levels) and Female teachers (% of total teachers) of Poland?
Your answer should be compact. -3.15. In the year 2005, what is the difference between the Female teachers (% of total teachers) of Finland and Female teachers (% of total teachers) of Ghana?
Ensure brevity in your answer.  45.66. In the year 2005, what is the difference between the Female teachers (% of total teachers) in Finland and Female teachers (% of total teachers) in Poland?
Offer a very short reply. -4.66. In the year 2005, what is the difference between the Female teachers (% of total teachers) of Ghana and Female teachers (% of total teachers) of Poland?
Make the answer very short. -50.32. In the year 2007, what is the difference between the Female teachers (% of total teachers) in Latin America(all income levels) and Female teachers (% of total teachers) in Finland?
Your response must be concise. -5.31. In the year 2007, what is the difference between the Female teachers (% of total teachers) of Latin America(all income levels) and Female teachers (% of total teachers) of Ghana?
Ensure brevity in your answer.  35.75. In the year 2007, what is the difference between the Female teachers (% of total teachers) of Latin America(all income levels) and Female teachers (% of total teachers) of Poland?
Give a very brief answer. -10.47. In the year 2007, what is the difference between the Female teachers (% of total teachers) in Finland and Female teachers (% of total teachers) in Ghana?
Provide a succinct answer. 41.06. In the year 2007, what is the difference between the Female teachers (% of total teachers) in Finland and Female teachers (% of total teachers) in Poland?
Your response must be concise. -5.16. In the year 2007, what is the difference between the Female teachers (% of total teachers) of Ghana and Female teachers (% of total teachers) of Poland?
Your answer should be compact. -46.22. In the year 2008, what is the difference between the Female teachers (% of total teachers) in Latin America(all income levels) and Female teachers (% of total teachers) in Finland?
Your answer should be compact. -4.16. In the year 2008, what is the difference between the Female teachers (% of total teachers) in Latin America(all income levels) and Female teachers (% of total teachers) in Ghana?
Offer a terse response. 37.43. In the year 2008, what is the difference between the Female teachers (% of total teachers) in Latin America(all income levels) and Female teachers (% of total teachers) in Poland?
Offer a very short reply. -10.28. In the year 2008, what is the difference between the Female teachers (% of total teachers) of Finland and Female teachers (% of total teachers) of Ghana?
Provide a short and direct response. 41.59. In the year 2008, what is the difference between the Female teachers (% of total teachers) in Finland and Female teachers (% of total teachers) in Poland?
Your answer should be very brief. -6.12. In the year 2008, what is the difference between the Female teachers (% of total teachers) of Ghana and Female teachers (% of total teachers) of Poland?
Ensure brevity in your answer.  -47.71. In the year 2009, what is the difference between the Female teachers (% of total teachers) in Latin America(all income levels) and Female teachers (% of total teachers) in Finland?
Provide a short and direct response. -4.62. In the year 2009, what is the difference between the Female teachers (% of total teachers) of Latin America(all income levels) and Female teachers (% of total teachers) of Ghana?
Offer a very short reply. 37.33. In the year 2009, what is the difference between the Female teachers (% of total teachers) of Latin America(all income levels) and Female teachers (% of total teachers) of Poland?
Provide a short and direct response. -10.09. In the year 2009, what is the difference between the Female teachers (% of total teachers) in Finland and Female teachers (% of total teachers) in Ghana?
Make the answer very short. 41.95. In the year 2009, what is the difference between the Female teachers (% of total teachers) in Finland and Female teachers (% of total teachers) in Poland?
Make the answer very short. -5.47. In the year 2009, what is the difference between the Female teachers (% of total teachers) in Ghana and Female teachers (% of total teachers) in Poland?
Give a very brief answer. -47.42. In the year 2011, what is the difference between the Female teachers (% of total teachers) in Latin America(all income levels) and Female teachers (% of total teachers) in Finland?
Keep it short and to the point. -5.61. In the year 2011, what is the difference between the Female teachers (% of total teachers) in Latin America(all income levels) and Female teachers (% of total teachers) in Ghana?
Your answer should be compact. 34.94. In the year 2011, what is the difference between the Female teachers (% of total teachers) in Latin America(all income levels) and Female teachers (% of total teachers) in Poland?
Offer a very short reply. -10.5. In the year 2011, what is the difference between the Female teachers (% of total teachers) of Finland and Female teachers (% of total teachers) of Ghana?
Make the answer very short. 40.54. In the year 2011, what is the difference between the Female teachers (% of total teachers) in Finland and Female teachers (% of total teachers) in Poland?
Offer a very short reply. -4.89. In the year 2011, what is the difference between the Female teachers (% of total teachers) of Ghana and Female teachers (% of total teachers) of Poland?
Your answer should be very brief. -45.43. In the year 2012, what is the difference between the Female teachers (% of total teachers) of Latin America(all income levels) and Female teachers (% of total teachers) of Finland?
Make the answer very short. -5.57. In the year 2012, what is the difference between the Female teachers (% of total teachers) of Latin America(all income levels) and Female teachers (% of total teachers) of Ghana?
Give a very brief answer. 34.8. In the year 2012, what is the difference between the Female teachers (% of total teachers) of Latin America(all income levels) and Female teachers (% of total teachers) of Poland?
Your answer should be compact. -10.34. In the year 2012, what is the difference between the Female teachers (% of total teachers) in Finland and Female teachers (% of total teachers) in Ghana?
Give a very brief answer. 40.37. In the year 2012, what is the difference between the Female teachers (% of total teachers) in Finland and Female teachers (% of total teachers) in Poland?
Keep it short and to the point. -4.76. In the year 2012, what is the difference between the Female teachers (% of total teachers) of Ghana and Female teachers (% of total teachers) of Poland?
Offer a terse response. -45.14. What is the ratio of the Female teachers (% of total teachers) of Latin America(all income levels) in 2001 to that in 2003?
Your response must be concise. 0.95. What is the ratio of the Female teachers (% of total teachers) in Finland in 2001 to that in 2003?
Give a very brief answer. 1. What is the ratio of the Female teachers (% of total teachers) in Ghana in 2001 to that in 2003?
Your answer should be very brief. 1.1. What is the ratio of the Female teachers (% of total teachers) of Poland in 2001 to that in 2003?
Your answer should be compact. 0.96. What is the ratio of the Female teachers (% of total teachers) of Latin America(all income levels) in 2001 to that in 2005?
Ensure brevity in your answer.  0.94. What is the ratio of the Female teachers (% of total teachers) in Finland in 2001 to that in 2005?
Give a very brief answer. 0.99. What is the ratio of the Female teachers (% of total teachers) of Ghana in 2001 to that in 2005?
Offer a terse response. 1.21. What is the ratio of the Female teachers (% of total teachers) of Poland in 2001 to that in 2005?
Your answer should be compact. 0.95. What is the ratio of the Female teachers (% of total teachers) of Latin America(all income levels) in 2001 to that in 2007?
Give a very brief answer. 1.05. What is the ratio of the Female teachers (% of total teachers) in Ghana in 2001 to that in 2007?
Provide a short and direct response. 0.96. What is the ratio of the Female teachers (% of total teachers) of Poland in 2001 to that in 2007?
Ensure brevity in your answer.  0.94. What is the ratio of the Female teachers (% of total teachers) in Latin America(all income levels) in 2001 to that in 2008?
Offer a terse response. 1.05. What is the ratio of the Female teachers (% of total teachers) of Ghana in 2001 to that in 2008?
Your answer should be very brief. 1.03. What is the ratio of the Female teachers (% of total teachers) of Poland in 2001 to that in 2008?
Offer a terse response. 0.94. What is the ratio of the Female teachers (% of total teachers) in Latin America(all income levels) in 2001 to that in 2009?
Give a very brief answer. 1.04. What is the ratio of the Female teachers (% of total teachers) in Ghana in 2001 to that in 2009?
Give a very brief answer. 1.02. What is the ratio of the Female teachers (% of total teachers) of Poland in 2001 to that in 2009?
Give a very brief answer. 0.94. What is the ratio of the Female teachers (% of total teachers) of Latin America(all income levels) in 2001 to that in 2011?
Keep it short and to the point. 1.05. What is the ratio of the Female teachers (% of total teachers) of Finland in 2001 to that in 2011?
Keep it short and to the point. 0.99. What is the ratio of the Female teachers (% of total teachers) of Ghana in 2001 to that in 2011?
Ensure brevity in your answer.  0.94. What is the ratio of the Female teachers (% of total teachers) in Poland in 2001 to that in 2011?
Make the answer very short. 0.94. What is the ratio of the Female teachers (% of total teachers) in Latin America(all income levels) in 2001 to that in 2012?
Give a very brief answer. 1.05. What is the ratio of the Female teachers (% of total teachers) of Finland in 2001 to that in 2012?
Ensure brevity in your answer.  0.99. What is the ratio of the Female teachers (% of total teachers) of Ghana in 2001 to that in 2012?
Keep it short and to the point. 0.93. What is the ratio of the Female teachers (% of total teachers) of Poland in 2001 to that in 2012?
Provide a short and direct response. 0.94. What is the ratio of the Female teachers (% of total teachers) in Finland in 2003 to that in 2005?
Offer a terse response. 1. What is the ratio of the Female teachers (% of total teachers) in Ghana in 2003 to that in 2005?
Your answer should be very brief. 1.1. What is the ratio of the Female teachers (% of total teachers) in Latin America(all income levels) in 2003 to that in 2007?
Your answer should be very brief. 1.1. What is the ratio of the Female teachers (% of total teachers) of Finland in 2003 to that in 2007?
Your answer should be compact. 0.99. What is the ratio of the Female teachers (% of total teachers) in Ghana in 2003 to that in 2007?
Make the answer very short. 0.88. What is the ratio of the Female teachers (% of total teachers) in Poland in 2003 to that in 2007?
Your answer should be compact. 0.99. What is the ratio of the Female teachers (% of total teachers) of Latin America(all income levels) in 2003 to that in 2008?
Offer a very short reply. 1.1. What is the ratio of the Female teachers (% of total teachers) in Finland in 2003 to that in 2008?
Provide a short and direct response. 1.01. What is the ratio of the Female teachers (% of total teachers) of Ghana in 2003 to that in 2008?
Give a very brief answer. 0.94. What is the ratio of the Female teachers (% of total teachers) in Poland in 2003 to that in 2008?
Ensure brevity in your answer.  0.99. What is the ratio of the Female teachers (% of total teachers) of Latin America(all income levels) in 2003 to that in 2009?
Provide a short and direct response. 1.1. What is the ratio of the Female teachers (% of total teachers) of Ghana in 2003 to that in 2009?
Provide a succinct answer. 0.93. What is the ratio of the Female teachers (% of total teachers) of Poland in 2003 to that in 2009?
Your answer should be compact. 0.99. What is the ratio of the Female teachers (% of total teachers) in Latin America(all income levels) in 2003 to that in 2011?
Provide a succinct answer. 1.11. What is the ratio of the Female teachers (% of total teachers) in Finland in 2003 to that in 2011?
Keep it short and to the point. 0.99. What is the ratio of the Female teachers (% of total teachers) of Ghana in 2003 to that in 2011?
Ensure brevity in your answer.  0.86. What is the ratio of the Female teachers (% of total teachers) of Poland in 2003 to that in 2011?
Ensure brevity in your answer.  0.99. What is the ratio of the Female teachers (% of total teachers) of Latin America(all income levels) in 2003 to that in 2012?
Provide a succinct answer. 1.1. What is the ratio of the Female teachers (% of total teachers) of Finland in 2003 to that in 2012?
Make the answer very short. 0.99. What is the ratio of the Female teachers (% of total teachers) of Ghana in 2003 to that in 2012?
Ensure brevity in your answer.  0.84. What is the ratio of the Female teachers (% of total teachers) of Poland in 2003 to that in 2012?
Your answer should be very brief. 0.99. What is the ratio of the Female teachers (% of total teachers) of Latin America(all income levels) in 2005 to that in 2007?
Provide a short and direct response. 1.11. What is the ratio of the Female teachers (% of total teachers) of Finland in 2005 to that in 2007?
Offer a terse response. 1. What is the ratio of the Female teachers (% of total teachers) of Ghana in 2005 to that in 2007?
Your answer should be very brief. 0.79. What is the ratio of the Female teachers (% of total teachers) in Poland in 2005 to that in 2007?
Offer a terse response. 0.99. What is the ratio of the Female teachers (% of total teachers) in Latin America(all income levels) in 2005 to that in 2008?
Give a very brief answer. 1.11. What is the ratio of the Female teachers (% of total teachers) in Finland in 2005 to that in 2008?
Offer a terse response. 1.01. What is the ratio of the Female teachers (% of total teachers) of Ghana in 2005 to that in 2008?
Provide a short and direct response. 0.85. What is the ratio of the Female teachers (% of total teachers) of Latin America(all income levels) in 2005 to that in 2009?
Keep it short and to the point. 1.11. What is the ratio of the Female teachers (% of total teachers) in Ghana in 2005 to that in 2009?
Your answer should be very brief. 0.84. What is the ratio of the Female teachers (% of total teachers) of Latin America(all income levels) in 2005 to that in 2011?
Offer a terse response. 1.12. What is the ratio of the Female teachers (% of total teachers) in Finland in 2005 to that in 2011?
Provide a short and direct response. 1. What is the ratio of the Female teachers (% of total teachers) of Ghana in 2005 to that in 2011?
Your answer should be compact. 0.78. What is the ratio of the Female teachers (% of total teachers) in Latin America(all income levels) in 2005 to that in 2012?
Offer a very short reply. 1.11. What is the ratio of the Female teachers (% of total teachers) of Ghana in 2005 to that in 2012?
Your response must be concise. 0.76. What is the ratio of the Female teachers (% of total teachers) in Poland in 2005 to that in 2012?
Keep it short and to the point. 0.99. What is the ratio of the Female teachers (% of total teachers) of Latin America(all income levels) in 2007 to that in 2008?
Give a very brief answer. 1. What is the ratio of the Female teachers (% of total teachers) in Finland in 2007 to that in 2008?
Ensure brevity in your answer.  1.02. What is the ratio of the Female teachers (% of total teachers) in Ghana in 2007 to that in 2008?
Ensure brevity in your answer.  1.07. What is the ratio of the Female teachers (% of total teachers) in Finland in 2007 to that in 2009?
Keep it short and to the point. 1.01. What is the ratio of the Female teachers (% of total teachers) of Ghana in 2007 to that in 2009?
Give a very brief answer. 1.06. What is the ratio of the Female teachers (% of total teachers) of Poland in 2007 to that in 2009?
Make the answer very short. 1. What is the ratio of the Female teachers (% of total teachers) in Latin America(all income levels) in 2007 to that in 2011?
Ensure brevity in your answer.  1. What is the ratio of the Female teachers (% of total teachers) of Ghana in 2007 to that in 2011?
Provide a short and direct response. 0.98. What is the ratio of the Female teachers (% of total teachers) of Poland in 2007 to that in 2011?
Offer a very short reply. 1. What is the ratio of the Female teachers (% of total teachers) of Finland in 2007 to that in 2012?
Make the answer very short. 1. What is the ratio of the Female teachers (% of total teachers) of Ghana in 2007 to that in 2012?
Make the answer very short. 0.96. What is the ratio of the Female teachers (% of total teachers) of Latin America(all income levels) in 2008 to that in 2009?
Your answer should be compact. 1. What is the ratio of the Female teachers (% of total teachers) of Latin America(all income levels) in 2008 to that in 2011?
Offer a terse response. 1.01. What is the ratio of the Female teachers (% of total teachers) of Ghana in 2008 to that in 2011?
Provide a succinct answer. 0.91. What is the ratio of the Female teachers (% of total teachers) of Poland in 2008 to that in 2011?
Ensure brevity in your answer.  1. What is the ratio of the Female teachers (% of total teachers) of Finland in 2008 to that in 2012?
Ensure brevity in your answer.  0.98. What is the ratio of the Female teachers (% of total teachers) in Ghana in 2008 to that in 2012?
Your response must be concise. 0.9. What is the ratio of the Female teachers (% of total teachers) of Poland in 2008 to that in 2012?
Make the answer very short. 1. What is the ratio of the Female teachers (% of total teachers) in Latin America(all income levels) in 2009 to that in 2011?
Offer a terse response. 1.01. What is the ratio of the Female teachers (% of total teachers) of Finland in 2009 to that in 2011?
Your response must be concise. 0.99. What is the ratio of the Female teachers (% of total teachers) of Ghana in 2009 to that in 2011?
Make the answer very short. 0.92. What is the ratio of the Female teachers (% of total teachers) of Finland in 2009 to that in 2012?
Your answer should be compact. 0.99. What is the ratio of the Female teachers (% of total teachers) in Ghana in 2009 to that in 2012?
Give a very brief answer. 0.91. What is the ratio of the Female teachers (% of total teachers) in Latin America(all income levels) in 2011 to that in 2012?
Make the answer very short. 1. What is the ratio of the Female teachers (% of total teachers) in Finland in 2011 to that in 2012?
Provide a succinct answer. 1. What is the ratio of the Female teachers (% of total teachers) in Ghana in 2011 to that in 2012?
Offer a very short reply. 0.99. What is the ratio of the Female teachers (% of total teachers) of Poland in 2011 to that in 2012?
Provide a succinct answer. 1. What is the difference between the highest and the second highest Female teachers (% of total teachers) of Latin America(all income levels)?
Offer a terse response. 0.51. What is the difference between the highest and the second highest Female teachers (% of total teachers) in Finland?
Ensure brevity in your answer.  0.18. What is the difference between the highest and the second highest Female teachers (% of total teachers) of Ghana?
Your answer should be very brief. 0.35. What is the difference between the highest and the second highest Female teachers (% of total teachers) of Poland?
Your answer should be very brief. 0.05. What is the difference between the highest and the lowest Female teachers (% of total teachers) of Latin America(all income levels)?
Give a very brief answer. 6.82. What is the difference between the highest and the lowest Female teachers (% of total teachers) of Finland?
Give a very brief answer. 1.22. What is the difference between the highest and the lowest Female teachers (% of total teachers) of Ghana?
Your response must be concise. 5.77. What is the difference between the highest and the lowest Female teachers (% of total teachers) of Poland?
Offer a terse response. 4.08. 